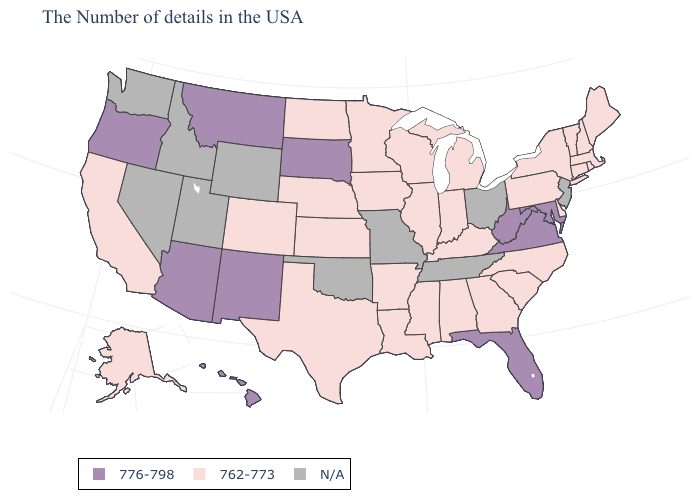Does Virginia have the highest value in the USA?
Be succinct. Yes. Does Texas have the lowest value in the South?
Answer briefly. Yes. Name the states that have a value in the range 776-798?
Write a very short answer. Maryland, Virginia, West Virginia, Florida, South Dakota, New Mexico, Montana, Arizona, Oregon, Hawaii. Name the states that have a value in the range N/A?
Give a very brief answer. New Jersey, Ohio, Tennessee, Missouri, Oklahoma, Wyoming, Utah, Idaho, Nevada, Washington. Name the states that have a value in the range N/A?
Short answer required. New Jersey, Ohio, Tennessee, Missouri, Oklahoma, Wyoming, Utah, Idaho, Nevada, Washington. What is the highest value in the USA?
Be succinct. 776-798. Which states have the lowest value in the Northeast?
Short answer required. Maine, Massachusetts, Rhode Island, New Hampshire, Vermont, Connecticut, New York, Pennsylvania. Name the states that have a value in the range N/A?
Concise answer only. New Jersey, Ohio, Tennessee, Missouri, Oklahoma, Wyoming, Utah, Idaho, Nevada, Washington. What is the value of Illinois?
Quick response, please. 762-773. Name the states that have a value in the range 762-773?
Write a very short answer. Maine, Massachusetts, Rhode Island, New Hampshire, Vermont, Connecticut, New York, Delaware, Pennsylvania, North Carolina, South Carolina, Georgia, Michigan, Kentucky, Indiana, Alabama, Wisconsin, Illinois, Mississippi, Louisiana, Arkansas, Minnesota, Iowa, Kansas, Nebraska, Texas, North Dakota, Colorado, California, Alaska. What is the value of Oregon?
Short answer required. 776-798. Name the states that have a value in the range 762-773?
Keep it brief. Maine, Massachusetts, Rhode Island, New Hampshire, Vermont, Connecticut, New York, Delaware, Pennsylvania, North Carolina, South Carolina, Georgia, Michigan, Kentucky, Indiana, Alabama, Wisconsin, Illinois, Mississippi, Louisiana, Arkansas, Minnesota, Iowa, Kansas, Nebraska, Texas, North Dakota, Colorado, California, Alaska. Name the states that have a value in the range 776-798?
Concise answer only. Maryland, Virginia, West Virginia, Florida, South Dakota, New Mexico, Montana, Arizona, Oregon, Hawaii. Name the states that have a value in the range 776-798?
Short answer required. Maryland, Virginia, West Virginia, Florida, South Dakota, New Mexico, Montana, Arizona, Oregon, Hawaii. 